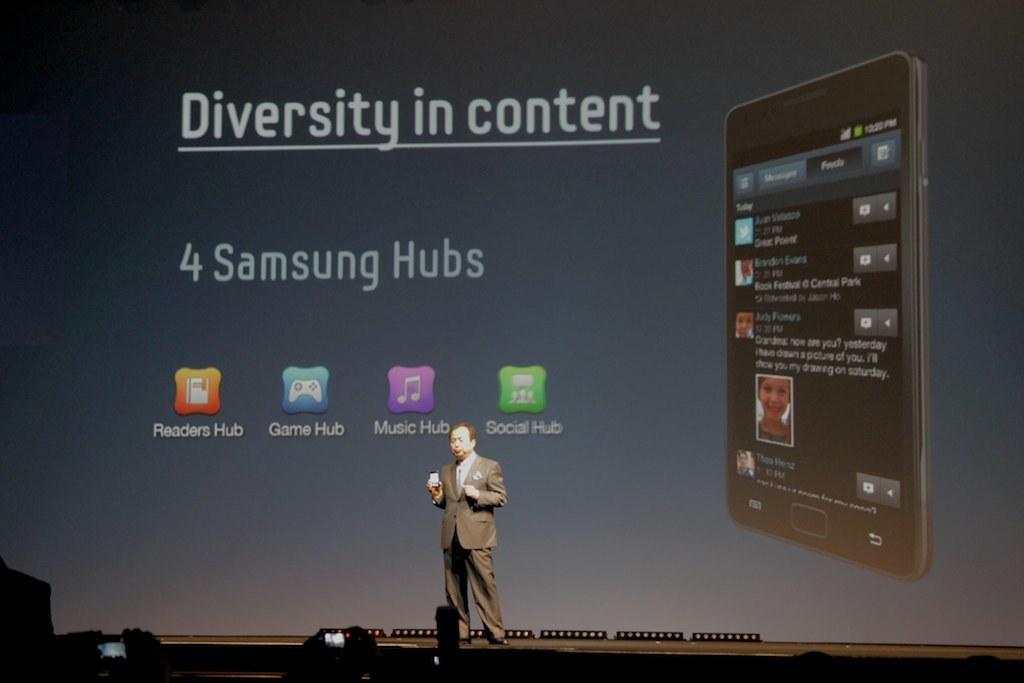How many samsung hubs are there?
Offer a terse response. 4. What is the left app?
Your response must be concise. Readers hub. 